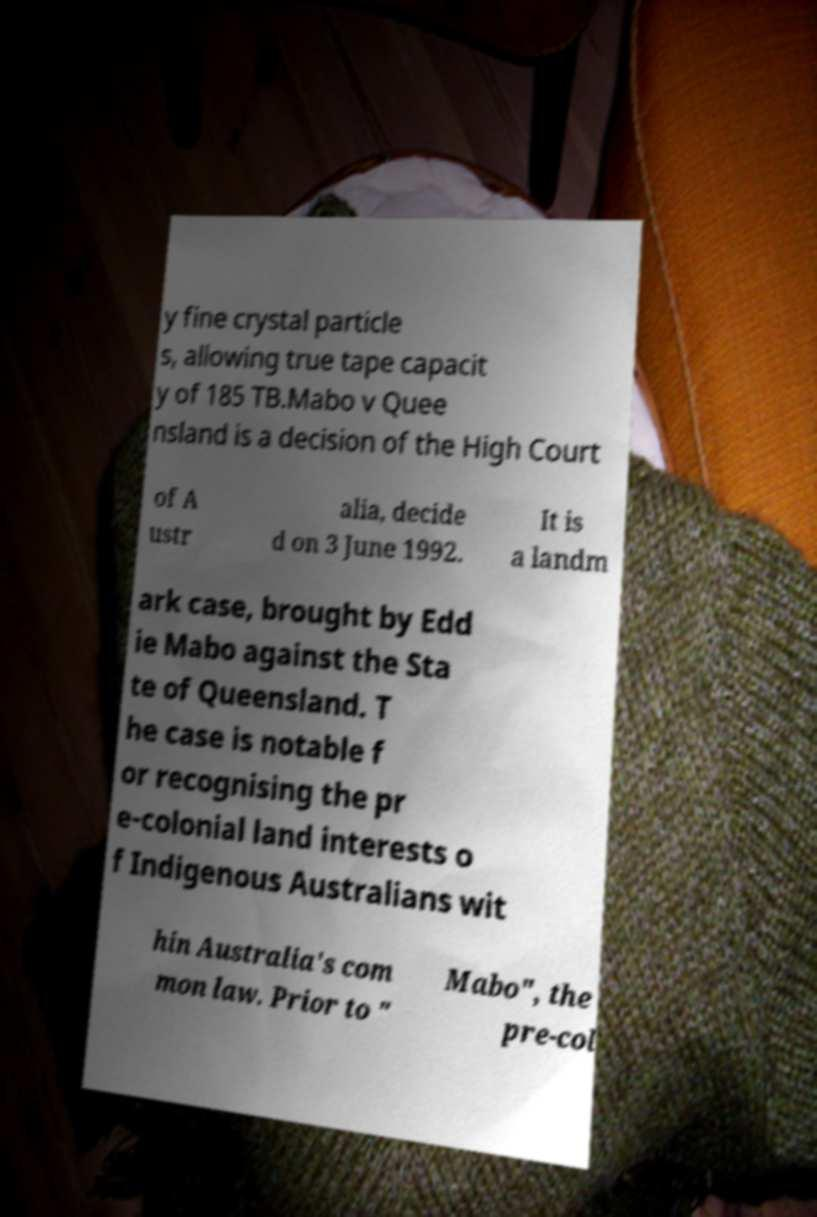Can you accurately transcribe the text from the provided image for me? y fine crystal particle s, allowing true tape capacit y of 185 TB.Mabo v Quee nsland is a decision of the High Court of A ustr alia, decide d on 3 June 1992. It is a landm ark case, brought by Edd ie Mabo against the Sta te of Queensland. T he case is notable f or recognising the pr e-colonial land interests o f Indigenous Australians wit hin Australia's com mon law. Prior to " Mabo", the pre-col 